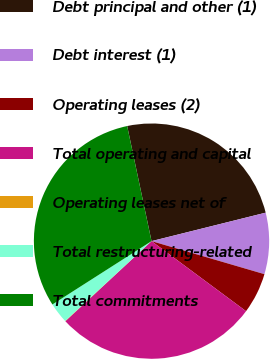Convert chart. <chart><loc_0><loc_0><loc_500><loc_500><pie_chart><fcel>Debt principal and other (1)<fcel>Debt interest (1)<fcel>Operating leases (2)<fcel>Total operating and capital<fcel>Operating leases net of<fcel>Total restructuring-related<fcel>Total commitments<nl><fcel>24.43%<fcel>8.42%<fcel>5.62%<fcel>27.93%<fcel>0.04%<fcel>2.83%<fcel>30.73%<nl></chart> 